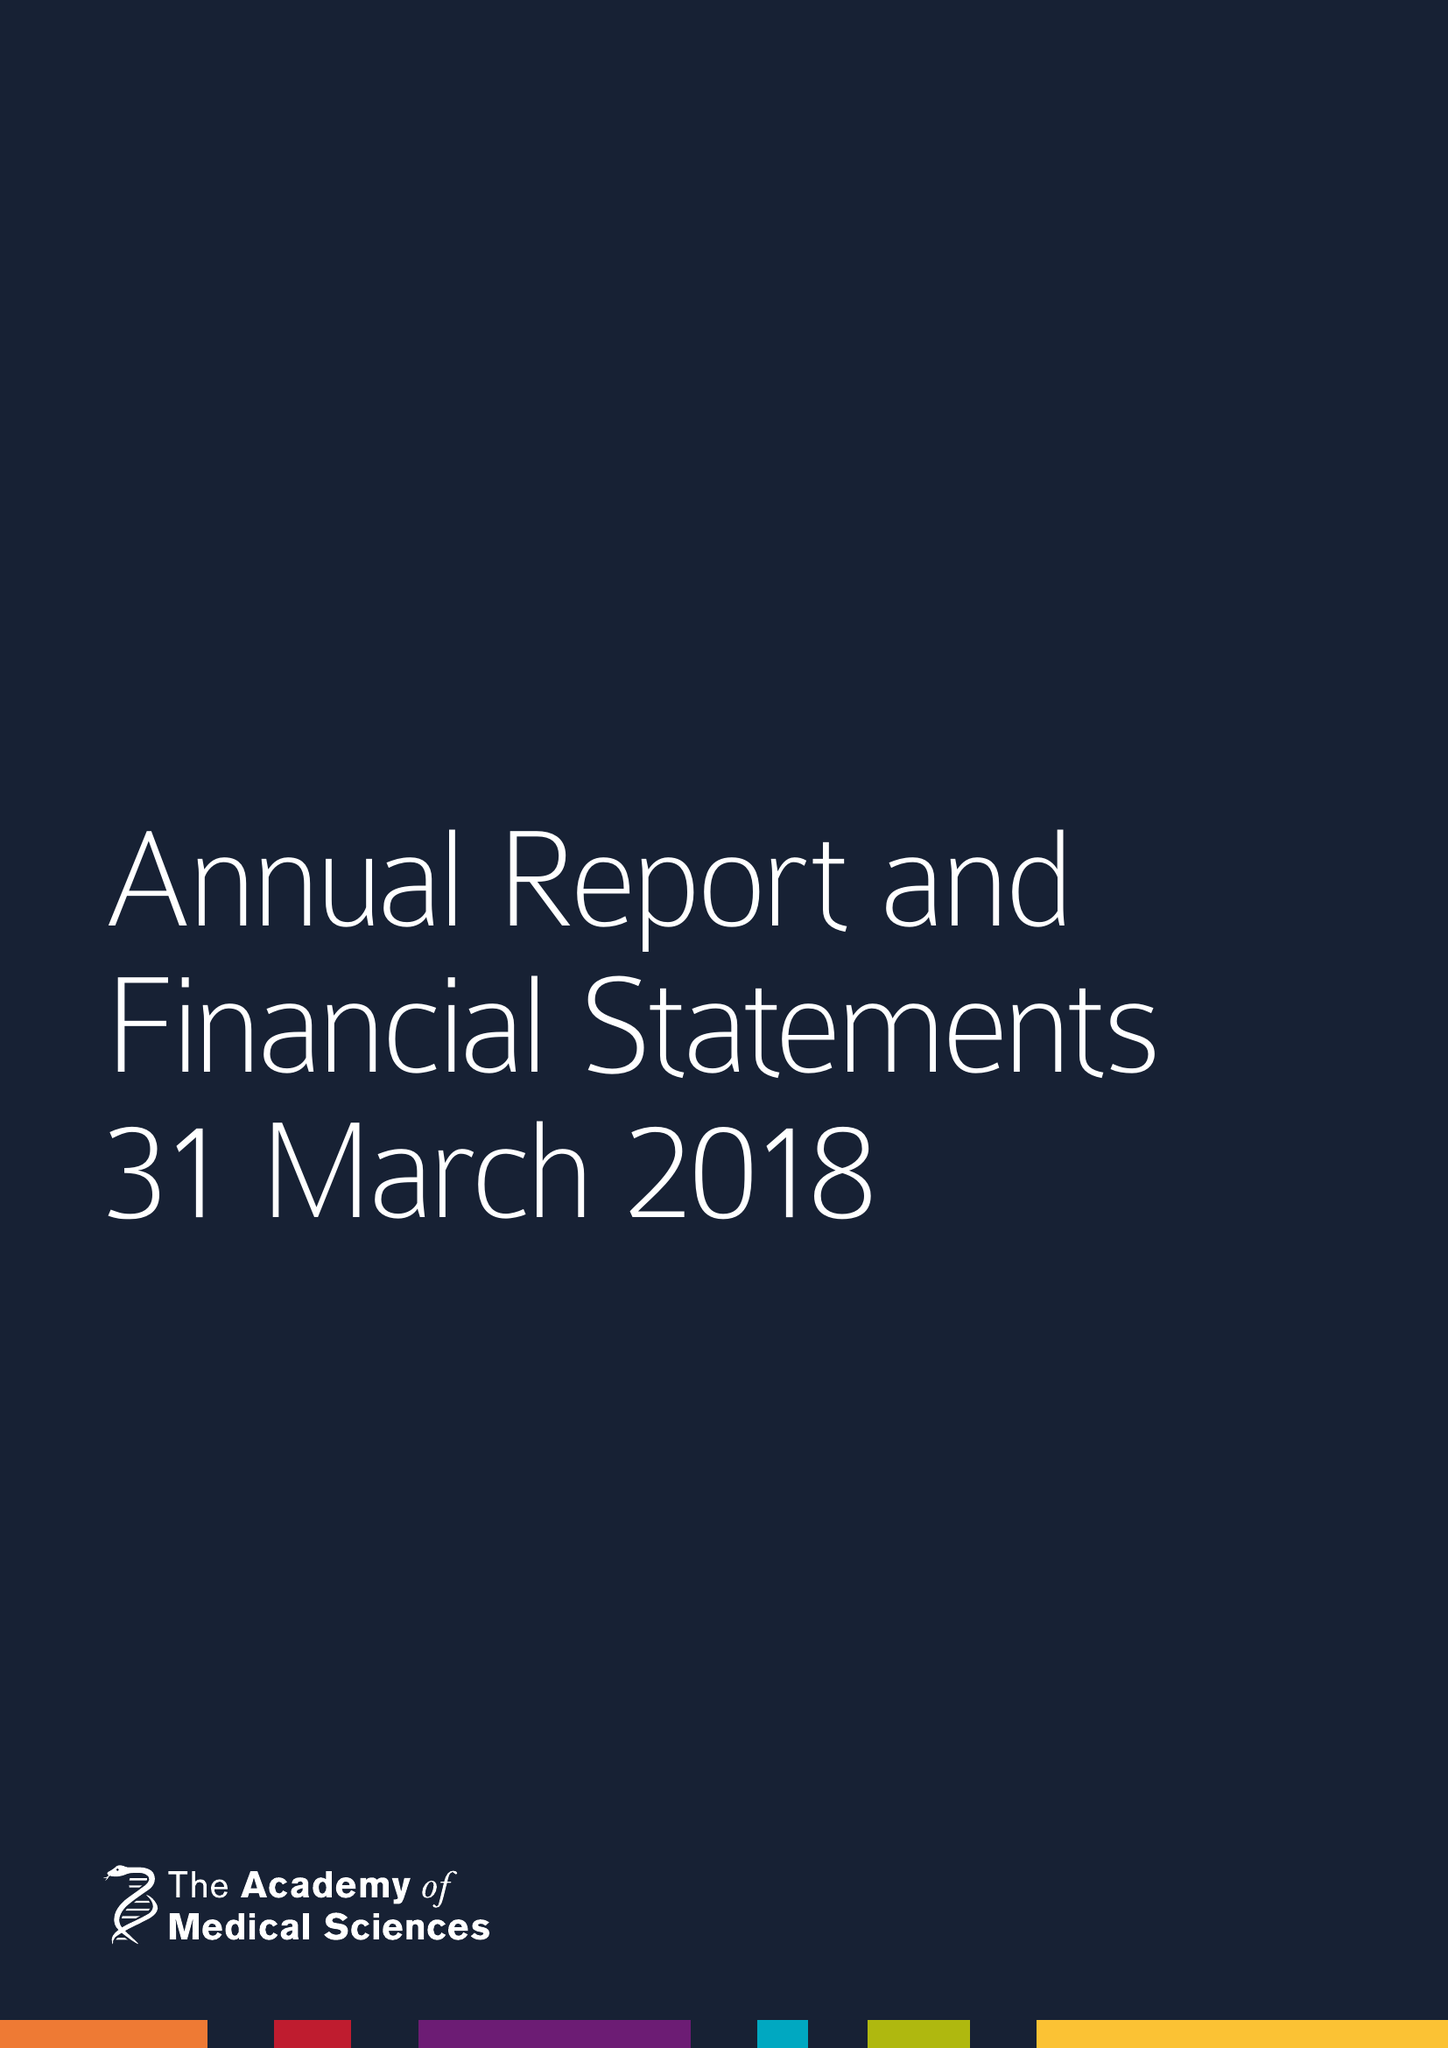What is the value for the charity_number?
Answer the question using a single word or phrase. 1070618 